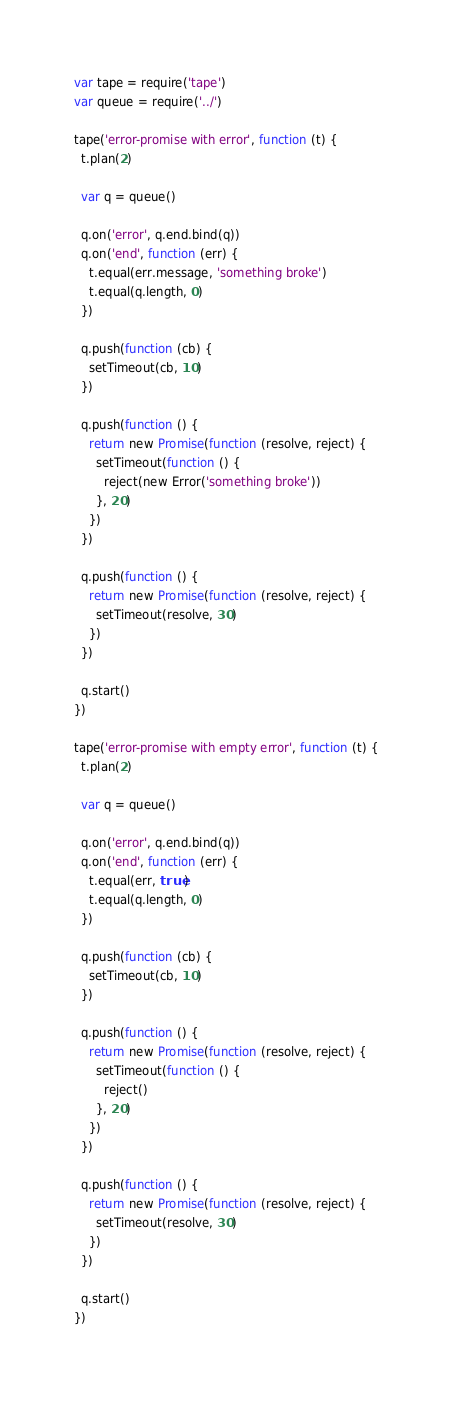Convert code to text. <code><loc_0><loc_0><loc_500><loc_500><_JavaScript_>var tape = require('tape')
var queue = require('../')

tape('error-promise with error', function (t) {
  t.plan(2)

  var q = queue()

  q.on('error', q.end.bind(q))
  q.on('end', function (err) {
    t.equal(err.message, 'something broke')
    t.equal(q.length, 0)
  })

  q.push(function (cb) {
    setTimeout(cb, 10)
  })

  q.push(function () {
    return new Promise(function (resolve, reject) {
      setTimeout(function () {
        reject(new Error('something broke'))
      }, 20)
    })
  })

  q.push(function () {
    return new Promise(function (resolve, reject) {
      setTimeout(resolve, 30)
    })
  })

  q.start()
})

tape('error-promise with empty error', function (t) {
  t.plan(2)

  var q = queue()

  q.on('error', q.end.bind(q))
  q.on('end', function (err) {
    t.equal(err, true)
    t.equal(q.length, 0)
  })

  q.push(function (cb) {
    setTimeout(cb, 10)
  })

  q.push(function () {
    return new Promise(function (resolve, reject) {
      setTimeout(function () {
        reject()
      }, 20)
    })
  })

  q.push(function () {
    return new Promise(function (resolve, reject) {
      setTimeout(resolve, 30)
    })
  })

  q.start()
})

</code> 